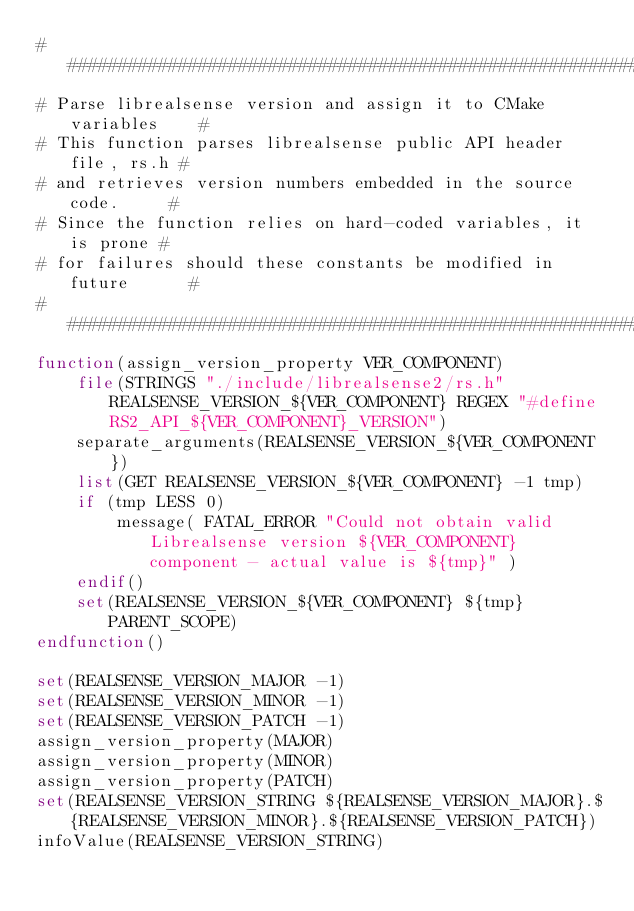Convert code to text. <code><loc_0><loc_0><loc_500><loc_500><_CMake_>##################################################################
# Parse librealsense version and assign it to CMake variables    #
# This function parses librealsense public API header file, rs.h #
# and retrieves version numbers embedded in the source code.     #
# Since the function relies on hard-coded variables, it is prone #
# for failures should these constants be modified in future      #
##################################################################
function(assign_version_property VER_COMPONENT)
    file(STRINGS "./include/librealsense2/rs.h" REALSENSE_VERSION_${VER_COMPONENT} REGEX "#define RS2_API_${VER_COMPONENT}_VERSION")
    separate_arguments(REALSENSE_VERSION_${VER_COMPONENT})
    list(GET REALSENSE_VERSION_${VER_COMPONENT} -1 tmp)
    if (tmp LESS 0)
        message( FATAL_ERROR "Could not obtain valid Librealsense version ${VER_COMPONENT} component - actual value is ${tmp}" )
    endif()
    set(REALSENSE_VERSION_${VER_COMPONENT} ${tmp} PARENT_SCOPE)
endfunction()

set(REALSENSE_VERSION_MAJOR -1)
set(REALSENSE_VERSION_MINOR -1)
set(REALSENSE_VERSION_PATCH -1)
assign_version_property(MAJOR)
assign_version_property(MINOR)
assign_version_property(PATCH)
set(REALSENSE_VERSION_STRING ${REALSENSE_VERSION_MAJOR}.${REALSENSE_VERSION_MINOR}.${REALSENSE_VERSION_PATCH})
infoValue(REALSENSE_VERSION_STRING)
</code> 